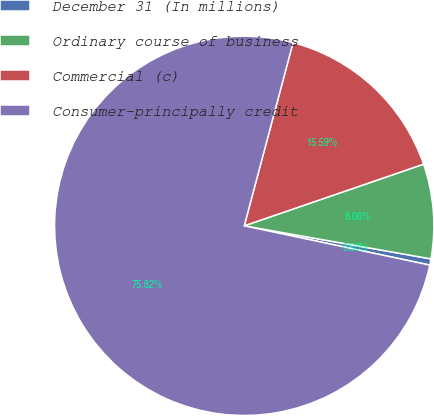Convert chart. <chart><loc_0><loc_0><loc_500><loc_500><pie_chart><fcel>December 31 (In millions)<fcel>Ordinary course of business<fcel>Commercial (c)<fcel>Consumer-principally credit<nl><fcel>0.53%<fcel>8.06%<fcel>15.59%<fcel>75.83%<nl></chart> 